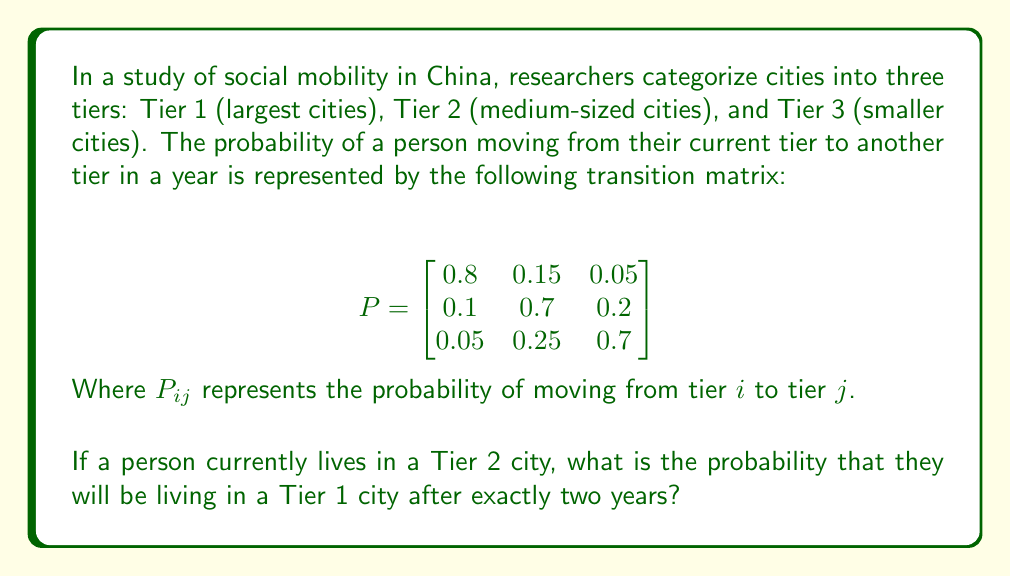Give your solution to this math problem. To solve this problem, we need to use the concept of matrix multiplication and the properties of Markov chains.

1) First, we need to calculate $P^2$, which represents the transition probabilities after two years.

2) We can compute $P^2$ as follows:

   $$P^2 = P \times P = \begin{bmatrix}
   0.8 & 0.15 & 0.05 \\
   0.1 & 0.7 & 0.2 \\
   0.05 & 0.25 & 0.7
   \end{bmatrix} \times \begin{bmatrix}
   0.8 & 0.15 & 0.05 \\
   0.1 & 0.7 & 0.2 \\
   0.05 & 0.25 & 0.7
   \end{bmatrix}$$

3) Performing the matrix multiplication:

   $$P^2 = \begin{bmatrix}
   0.655 & 0.2475 & 0.0975 \\
   0.17 & 0.605 & 0.225 \\
   0.1225 & 0.3375 & 0.54
   \end{bmatrix}$$

4) The person currently lives in a Tier 2 city, so we're interested in the second row of $P^2$.

5) The probability of moving from Tier 2 to Tier 1 after two years is given by the element in the second row, first column of $P^2$, which is 0.17.

Therefore, the probability that a person currently living in a Tier 2 city will be living in a Tier 1 city after exactly two years is 0.17 or 17%.
Answer: 0.17 